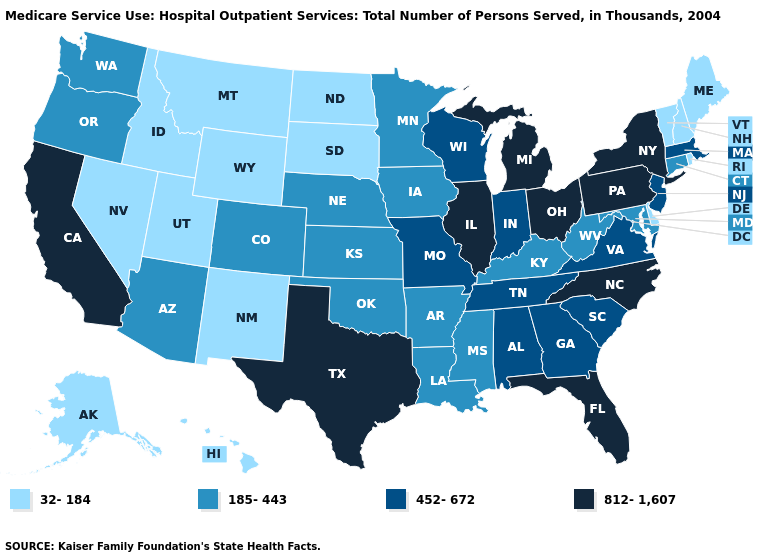What is the value of Louisiana?
Be succinct. 185-443. What is the value of New Hampshire?
Answer briefly. 32-184. Name the states that have a value in the range 812-1,607?
Quick response, please. California, Florida, Illinois, Michigan, New York, North Carolina, Ohio, Pennsylvania, Texas. What is the highest value in the South ?
Keep it brief. 812-1,607. What is the value of Tennessee?
Concise answer only. 452-672. Among the states that border Alabama , does Georgia have the highest value?
Short answer required. No. What is the highest value in the South ?
Quick response, please. 812-1,607. Name the states that have a value in the range 32-184?
Write a very short answer. Alaska, Delaware, Hawaii, Idaho, Maine, Montana, Nevada, New Hampshire, New Mexico, North Dakota, Rhode Island, South Dakota, Utah, Vermont, Wyoming. Does Iowa have the same value as Colorado?
Be succinct. Yes. Name the states that have a value in the range 812-1,607?
Write a very short answer. California, Florida, Illinois, Michigan, New York, North Carolina, Ohio, Pennsylvania, Texas. Which states have the lowest value in the USA?
Write a very short answer. Alaska, Delaware, Hawaii, Idaho, Maine, Montana, Nevada, New Hampshire, New Mexico, North Dakota, Rhode Island, South Dakota, Utah, Vermont, Wyoming. Name the states that have a value in the range 185-443?
Keep it brief. Arizona, Arkansas, Colorado, Connecticut, Iowa, Kansas, Kentucky, Louisiana, Maryland, Minnesota, Mississippi, Nebraska, Oklahoma, Oregon, Washington, West Virginia. What is the value of Alabama?
Keep it brief. 452-672. What is the lowest value in states that border Delaware?
Short answer required. 185-443. 